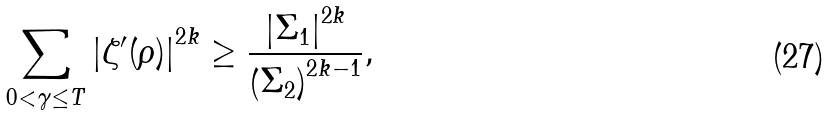Convert formula to latex. <formula><loc_0><loc_0><loc_500><loc_500>\sum _ { 0 < \gamma \leq T } \left | \zeta ^ { \prime } ( \rho ) \right | ^ { 2 k } \geq \frac { \left | \Sigma _ { 1 } \right | ^ { 2 k } } { \left ( \Sigma _ { 2 } \right ) ^ { 2 k - 1 } } ,</formula> 